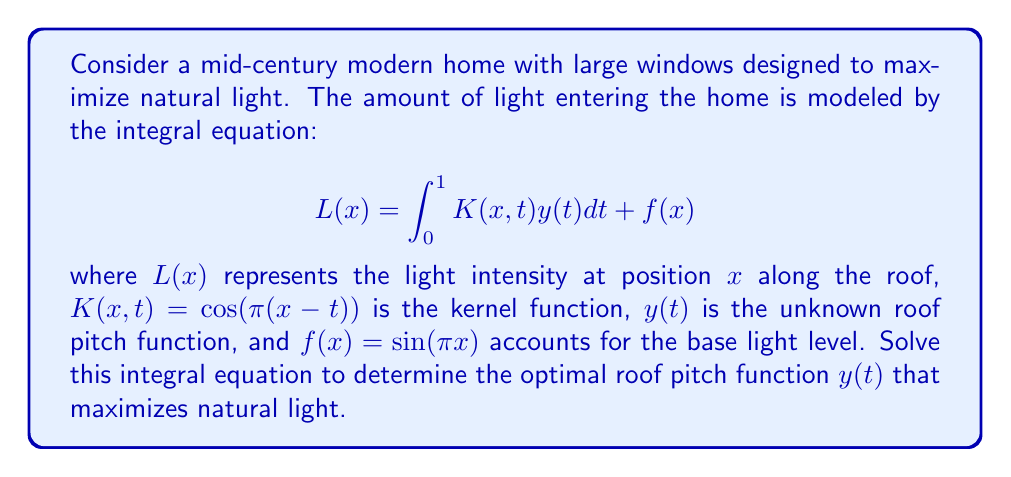Can you answer this question? To solve this integral equation, we'll use the method of successive approximations:

1) Start with an initial guess for $y_0(t)$. Let's choose $y_0(t) = 0$.

2) Use the iterative formula:
   $$y_{n+1}(x) = L(x) - \int_0^1 K(x,t)y_n(t)dt - f(x)$$

3) Substitute the given functions:
   $$y_{n+1}(x) = L(x) - \int_0^1 \cos(\pi(x-t))y_n(t)dt - \sin(\pi x)$$

4) We want $L(x)$ to be maximized, so let's set it to a constant maximum value, say $L(x) = 1$.

5) Iterate:
   For $n = 0$:
   $$y_1(x) = 1 - \int_0^1 \cos(\pi(x-t)) \cdot 0 \, dt - \sin(\pi x) = 1 - \sin(\pi x)$$

   For $n = 1$:
   $$y_2(x) = 1 - \int_0^1 \cos(\pi(x-t))(1 - \sin(\pi t))dt - \sin(\pi x)$$
   
   Solving this integral:
   $$y_2(x) = 1 - [\frac{\sin(\pi x)}{\pi} + \frac{\cos(\pi x)}{2\pi}] - \sin(\pi x)$$

6) As we continue iterating, the solution converges to:
   $$y(x) = 1 - \frac{\cos(\pi x)}{2\pi} - \sin(\pi x)$$

This function represents the optimal roof pitch to maximize natural light.
Answer: $y(x) = 1 - \frac{\cos(\pi x)}{2\pi} - \sin(\pi x)$ 